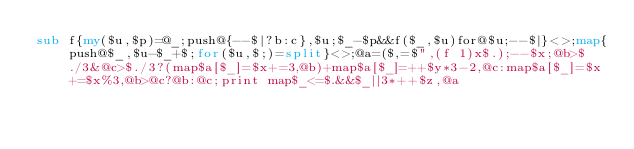Convert code to text. <code><loc_0><loc_0><loc_500><loc_500><_Perl_>sub f{my($u,$p)=@_;push@{--$|?b:c},$u;$_-$p&&f($_,$u)for@$u;--$|}<>;map{push@$_,$u-$_+$;for($u,$;)=split}<>;@a=($,=$",(f 1)x$.);--$x;@b>$./3&@c>$./3?(map$a[$_]=$x+=3,@b)+map$a[$_]=++$y*3-2,@c:map$a[$_]=$x+=$x%3,@b>@c?@b:@c;print map$_<=$.&&$_||3*++$z,@a</code> 